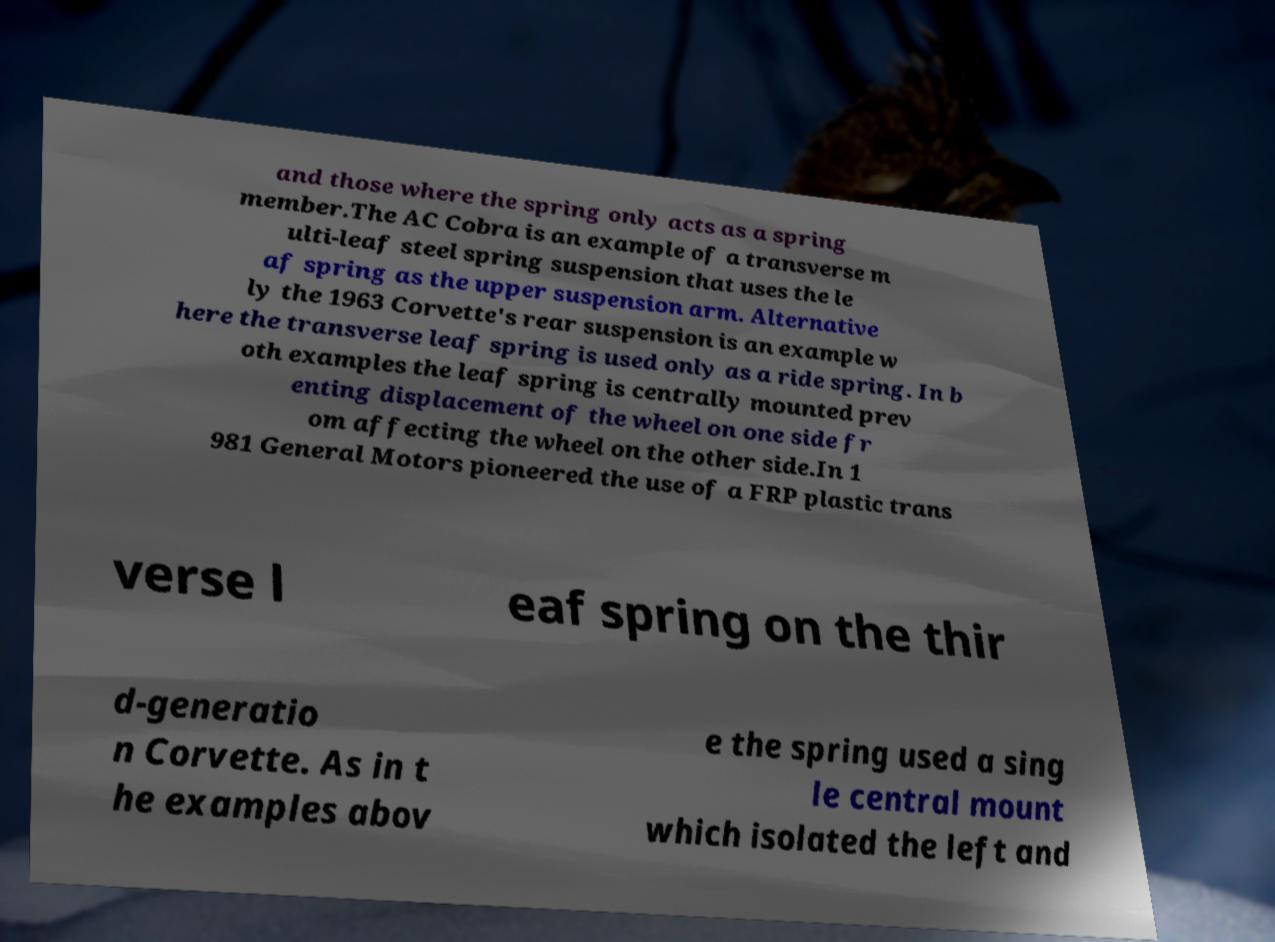What messages or text are displayed in this image? I need them in a readable, typed format. and those where the spring only acts as a spring member.The AC Cobra is an example of a transverse m ulti-leaf steel spring suspension that uses the le af spring as the upper suspension arm. Alternative ly the 1963 Corvette's rear suspension is an example w here the transverse leaf spring is used only as a ride spring. In b oth examples the leaf spring is centrally mounted prev enting displacement of the wheel on one side fr om affecting the wheel on the other side.In 1 981 General Motors pioneered the use of a FRP plastic trans verse l eaf spring on the thir d-generatio n Corvette. As in t he examples abov e the spring used a sing le central mount which isolated the left and 